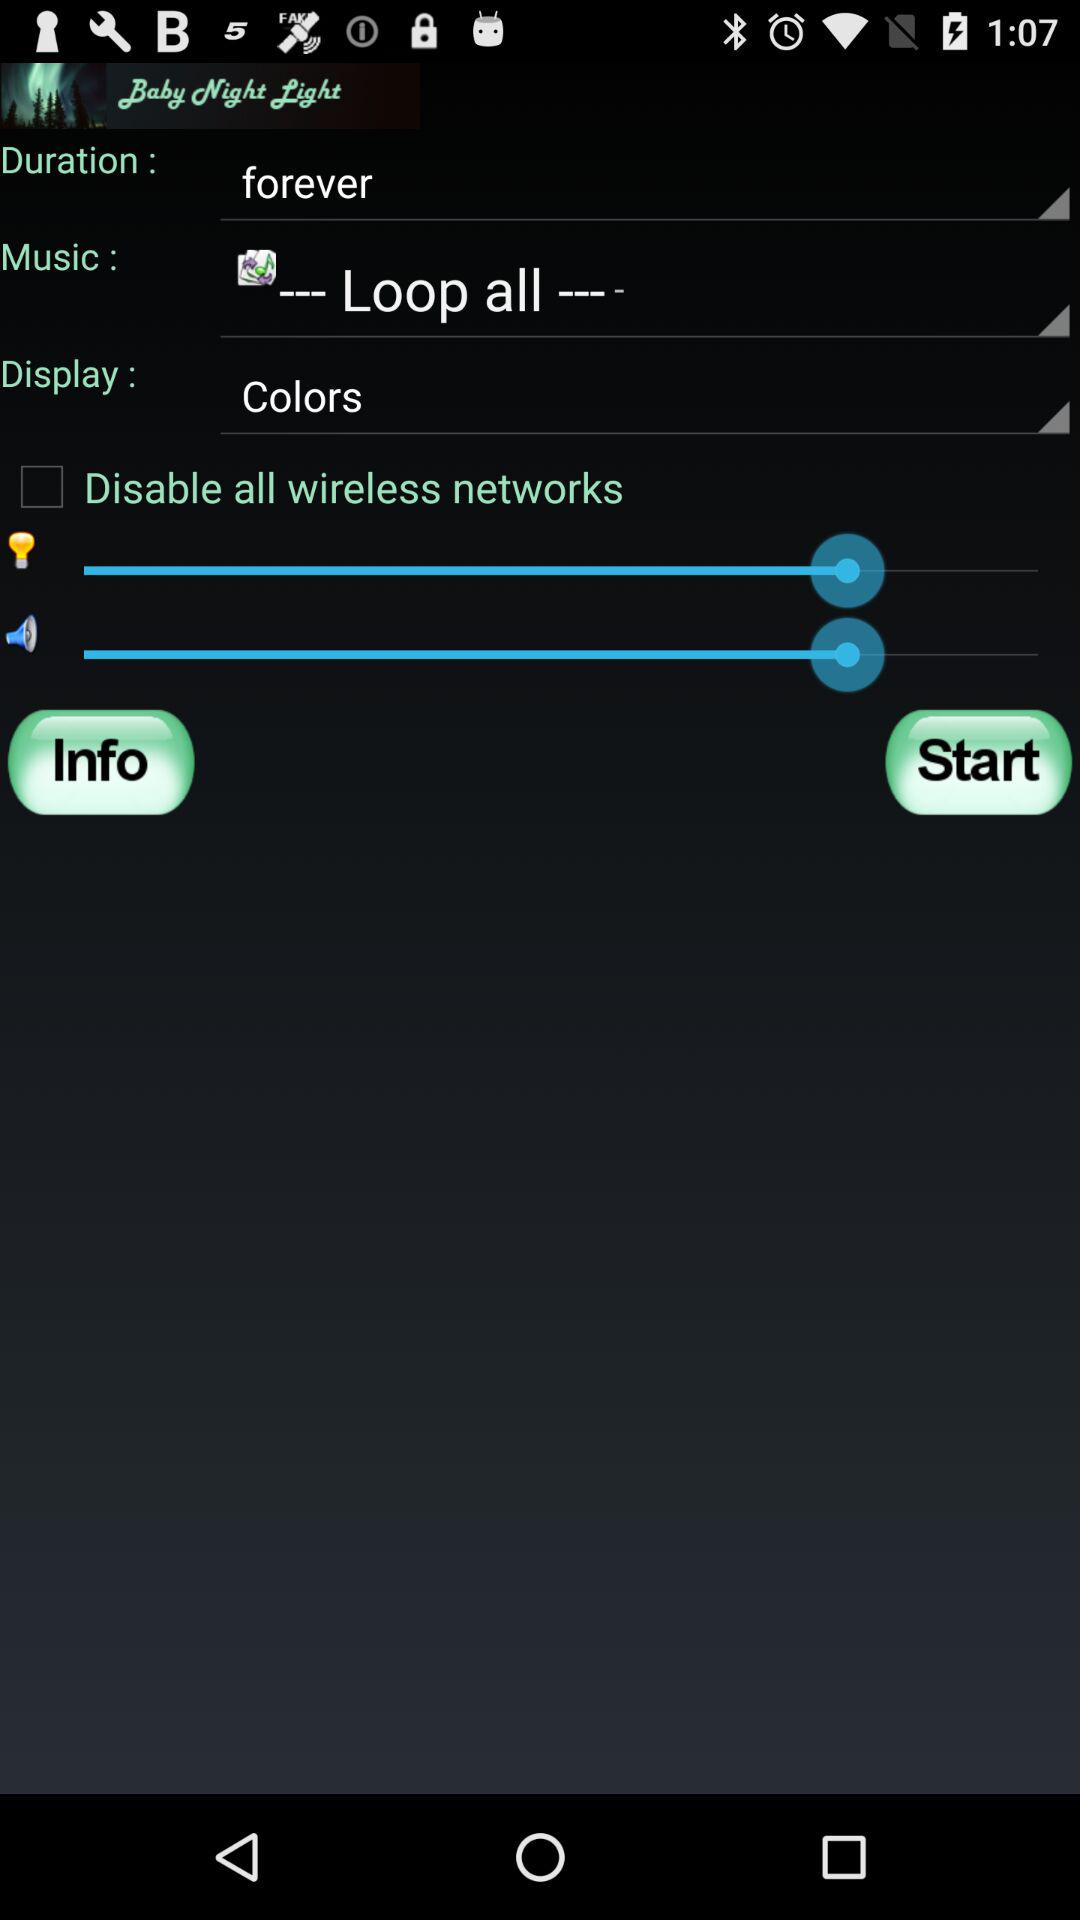What option is selected in "Display"? The selected option is "Colors". 